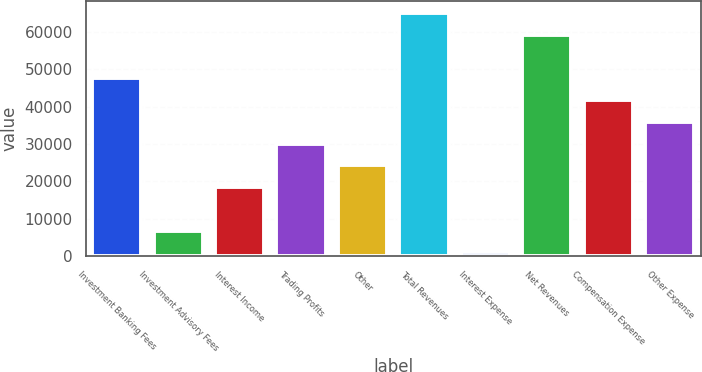Convert chart to OTSL. <chart><loc_0><loc_0><loc_500><loc_500><bar_chart><fcel>Investment Banking Fees<fcel>Investment Advisory Fees<fcel>Interest Income<fcel>Trading Profits<fcel>Other<fcel>Total Revenues<fcel>Interest Expense<fcel>Net Revenues<fcel>Compensation Expense<fcel>Other Expense<nl><fcel>47481.4<fcel>6875.8<fcel>18477.4<fcel>30079<fcel>24278.2<fcel>64883.8<fcel>1075<fcel>59083<fcel>41680.6<fcel>35879.8<nl></chart> 